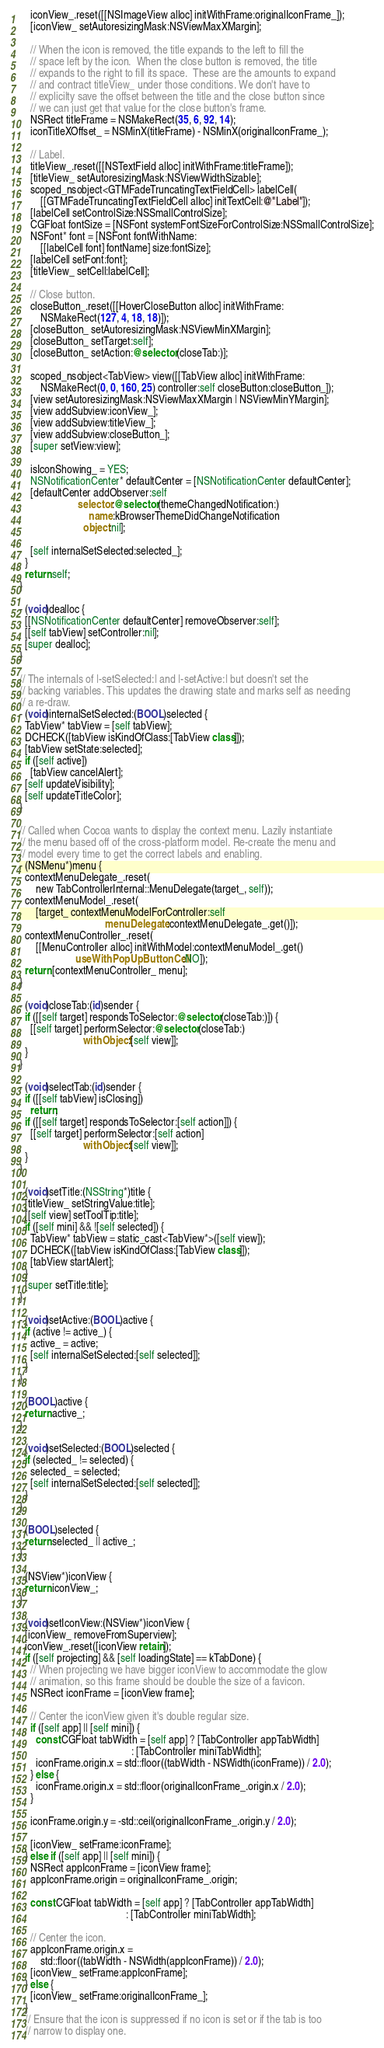Convert code to text. <code><loc_0><loc_0><loc_500><loc_500><_ObjectiveC_>    iconView_.reset([[NSImageView alloc] initWithFrame:originalIconFrame_]);
    [iconView_ setAutoresizingMask:NSViewMaxXMargin];

    // When the icon is removed, the title expands to the left to fill the
    // space left by the icon.  When the close button is removed, the title
    // expands to the right to fill its space.  These are the amounts to expand
    // and contract titleView_ under those conditions. We don't have to
    // explicilty save the offset between the title and the close button since
    // we can just get that value for the close button's frame.
    NSRect titleFrame = NSMakeRect(35, 6, 92, 14);
    iconTitleXOffset_ = NSMinX(titleFrame) - NSMinX(originalIconFrame_);

    // Label.
    titleView_.reset([[NSTextField alloc] initWithFrame:titleFrame]);
    [titleView_ setAutoresizingMask:NSViewWidthSizable];
    scoped_nsobject<GTMFadeTruncatingTextFieldCell> labelCell(
        [[GTMFadeTruncatingTextFieldCell alloc] initTextCell:@"Label"]);
    [labelCell setControlSize:NSSmallControlSize];
    CGFloat fontSize = [NSFont systemFontSizeForControlSize:NSSmallControlSize];
    NSFont* font = [NSFont fontWithName:
        [[labelCell font] fontName] size:fontSize];
    [labelCell setFont:font];
    [titleView_ setCell:labelCell];

    // Close button.
    closeButton_.reset([[HoverCloseButton alloc] initWithFrame:
        NSMakeRect(127, 4, 18, 18)]);
    [closeButton_ setAutoresizingMask:NSViewMinXMargin];
    [closeButton_ setTarget:self];
    [closeButton_ setAction:@selector(closeTab:)];

    scoped_nsobject<TabView> view([[TabView alloc] initWithFrame:
        NSMakeRect(0, 0, 160, 25) controller:self closeButton:closeButton_]);
    [view setAutoresizingMask:NSViewMaxXMargin | NSViewMinYMargin];
    [view addSubview:iconView_];
    [view addSubview:titleView_];
    [view addSubview:closeButton_];
    [super setView:view];

    isIconShowing_ = YES;
    NSNotificationCenter* defaultCenter = [NSNotificationCenter defaultCenter];
    [defaultCenter addObserver:self
                      selector:@selector(themeChangedNotification:)
                          name:kBrowserThemeDidChangeNotification
                        object:nil];

    [self internalSetSelected:selected_];
  }
  return self;
}

- (void)dealloc {
  [[NSNotificationCenter defaultCenter] removeObserver:self];
  [[self tabView] setController:nil];
  [super dealloc];
}

// The internals of |-setSelected:| and |-setActive:| but doesn't set the
// backing variables. This updates the drawing state and marks self as needing
// a re-draw.
- (void)internalSetSelected:(BOOL)selected {
  TabView* tabView = [self tabView];
  DCHECK([tabView isKindOfClass:[TabView class]]);
  [tabView setState:selected];
  if ([self active])
    [tabView cancelAlert];
  [self updateVisibility];
  [self updateTitleColor];
}

// Called when Cocoa wants to display the context menu. Lazily instantiate
// the menu based off of the cross-platform model. Re-create the menu and
// model every time to get the correct labels and enabling.
- (NSMenu*)menu {
  contextMenuDelegate_.reset(
      new TabControllerInternal::MenuDelegate(target_, self));
  contextMenuModel_.reset(
      [target_ contextMenuModelForController:self
                                menuDelegate:contextMenuDelegate_.get()]);
  contextMenuController_.reset(
      [[MenuController alloc] initWithModel:contextMenuModel_.get()
                     useWithPopUpButtonCell:NO]);
  return [contextMenuController_ menu];
}

- (void)closeTab:(id)sender {
  if ([[self target] respondsToSelector:@selector(closeTab:)]) {
    [[self target] performSelector:@selector(closeTab:)
                        withObject:[self view]];
  }
}

- (void)selectTab:(id)sender {
  if ([[self tabView] isClosing])
    return;
  if ([[self target] respondsToSelector:[self action]]) {
    [[self target] performSelector:[self action]
                        withObject:[self view]];
  }
}

- (void)setTitle:(NSString*)title {
  [titleView_ setStringValue:title];
  [[self view] setToolTip:title];
  if ([self mini] && ![self selected]) {
    TabView* tabView = static_cast<TabView*>([self view]);
    DCHECK([tabView isKindOfClass:[TabView class]]);
    [tabView startAlert];
  }
  [super setTitle:title];
}

- (void)setActive:(BOOL)active {
  if (active != active_) {
    active_ = active;
    [self internalSetSelected:[self selected]];
  }
}

- (BOOL)active {
  return active_;
}

- (void)setSelected:(BOOL)selected {
  if (selected_ != selected) {
    selected_ = selected;
    [self internalSetSelected:[self selected]];
  }
}

- (BOOL)selected {
  return selected_ || active_;
}

- (NSView*)iconView {
  return iconView_;
}

- (void)setIconView:(NSView*)iconView {
  [iconView_ removeFromSuperview];
  iconView_.reset([iconView retain]);
  if ([self projecting] && [self loadingState] == kTabDone) {
    // When projecting we have bigger iconView to accommodate the glow
    // animation, so this frame should be double the size of a favicon.
    NSRect iconFrame = [iconView frame];

    // Center the iconView given it's double regular size.
    if ([self app] || [self mini]) {
      const CGFloat tabWidth = [self app] ? [TabController appTabWidth]
                                          : [TabController miniTabWidth];
      iconFrame.origin.x = std::floor((tabWidth - NSWidth(iconFrame)) / 2.0);
    } else {
      iconFrame.origin.x = std::floor(originalIconFrame_.origin.x / 2.0);
    }

    iconFrame.origin.y = -std::ceil(originalIconFrame_.origin.y / 2.0);

    [iconView_ setFrame:iconFrame];
  } else if ([self app] || [self mini]) {
    NSRect appIconFrame = [iconView frame];
    appIconFrame.origin = originalIconFrame_.origin;

    const CGFloat tabWidth = [self app] ? [TabController appTabWidth]
                                        : [TabController miniTabWidth];

    // Center the icon.
    appIconFrame.origin.x =
        std::floor((tabWidth - NSWidth(appIconFrame)) / 2.0);
    [iconView_ setFrame:appIconFrame];
  } else {
    [iconView_ setFrame:originalIconFrame_];
  }
  // Ensure that the icon is suppressed if no icon is set or if the tab is too
  // narrow to display one.</code> 